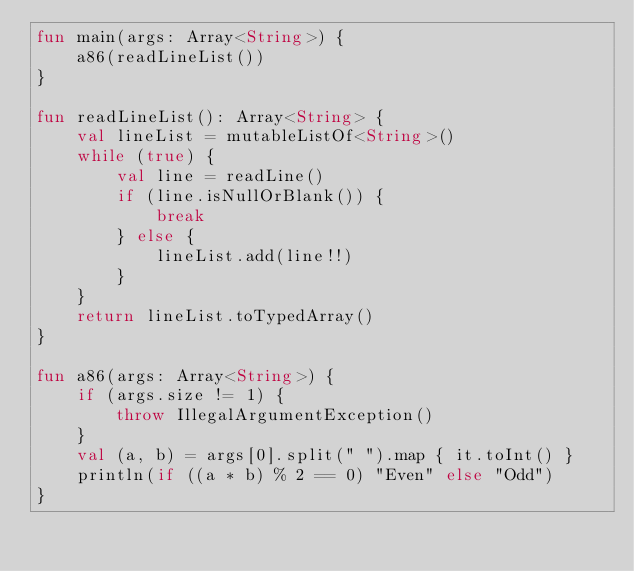Convert code to text. <code><loc_0><loc_0><loc_500><loc_500><_Kotlin_>fun main(args: Array<String>) {
    a86(readLineList())
}

fun readLineList(): Array<String> {
    val lineList = mutableListOf<String>()
    while (true) {
        val line = readLine()
        if (line.isNullOrBlank()) {
            break
        } else {
            lineList.add(line!!)
        }
    }
    return lineList.toTypedArray()
}

fun a86(args: Array<String>) {
    if (args.size != 1) {
        throw IllegalArgumentException()
    }
    val (a, b) = args[0].split(" ").map { it.toInt() }
    println(if ((a * b) % 2 == 0) "Even" else "Odd")
}</code> 